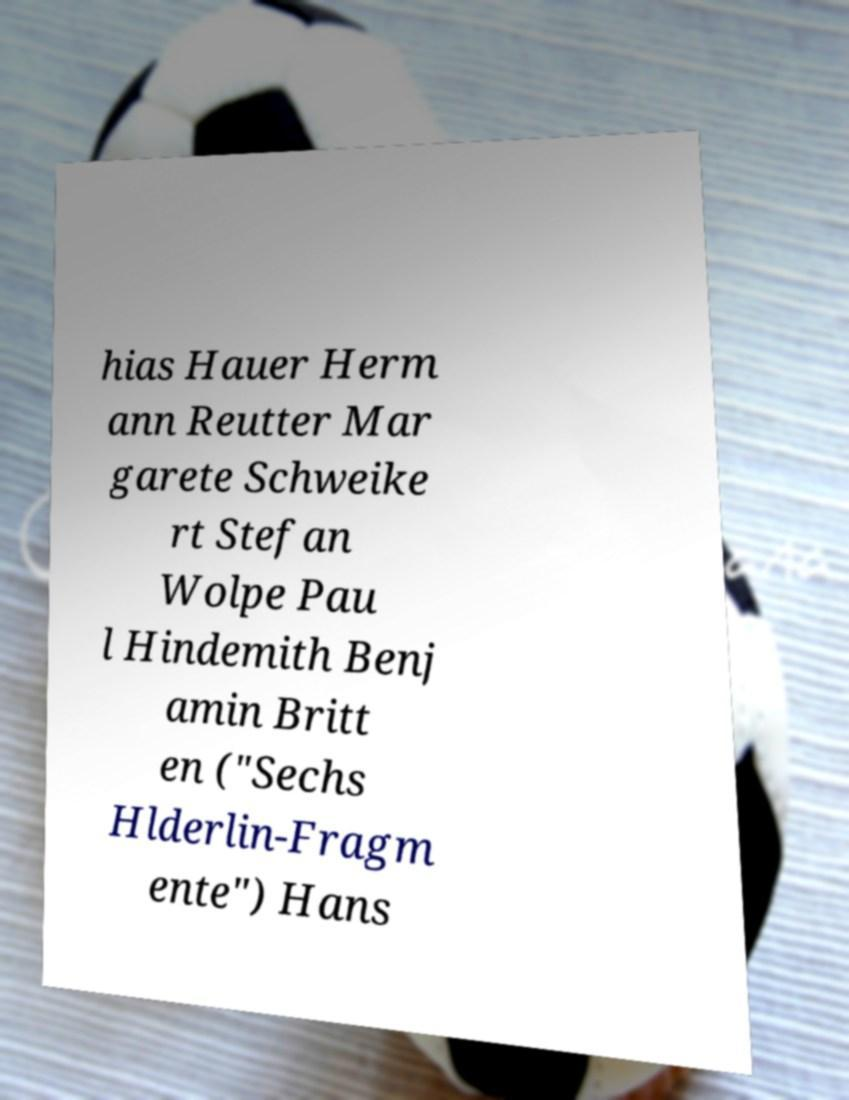There's text embedded in this image that I need extracted. Can you transcribe it verbatim? hias Hauer Herm ann Reutter Mar garete Schweike rt Stefan Wolpe Pau l Hindemith Benj amin Britt en ("Sechs Hlderlin-Fragm ente") Hans 